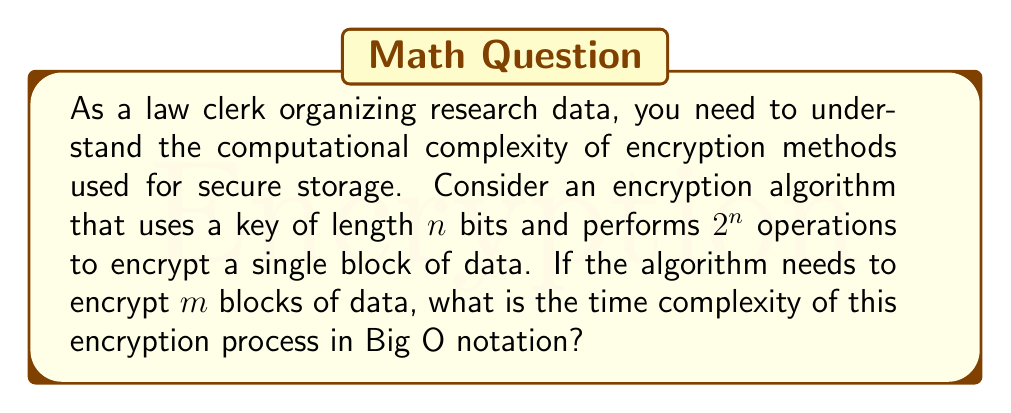Show me your answer to this math problem. To solve this problem, let's break it down step by step:

1. For a single block of data:
   - The algorithm performs $2^n$ operations
   - This is because the key length is $n$ bits, and the number of operations is exponential to the key length

2. For $m$ blocks of data:
   - The algorithm needs to repeat the encryption process $m$ times
   - So, the total number of operations will be $m \times 2^n$

3. In Big O notation:
   - We express the worst-case time complexity
   - The dominant factor here is $2^n$, as it grows much faster than $m$ for large values of $n$
   - However, we can't ignore $m$ as it's a separate input parameter

4. Therefore, the time complexity is:
   $$O(m \times 2^n)$$

This notation indicates that the time complexity grows exponentially with the key length $n$ and linearly with the number of data blocks $m$.

It's important to note that in practical encryption systems, key lengths are usually fixed (e.g., 128 or 256 bits for AES). In such cases, $2^n$ would be a constant, and the complexity would simplify to $O(m)$. However, for the purposes of this theoretical analysis, we consider $n$ as a variable.
Answer: $O(m \times 2^n)$ 